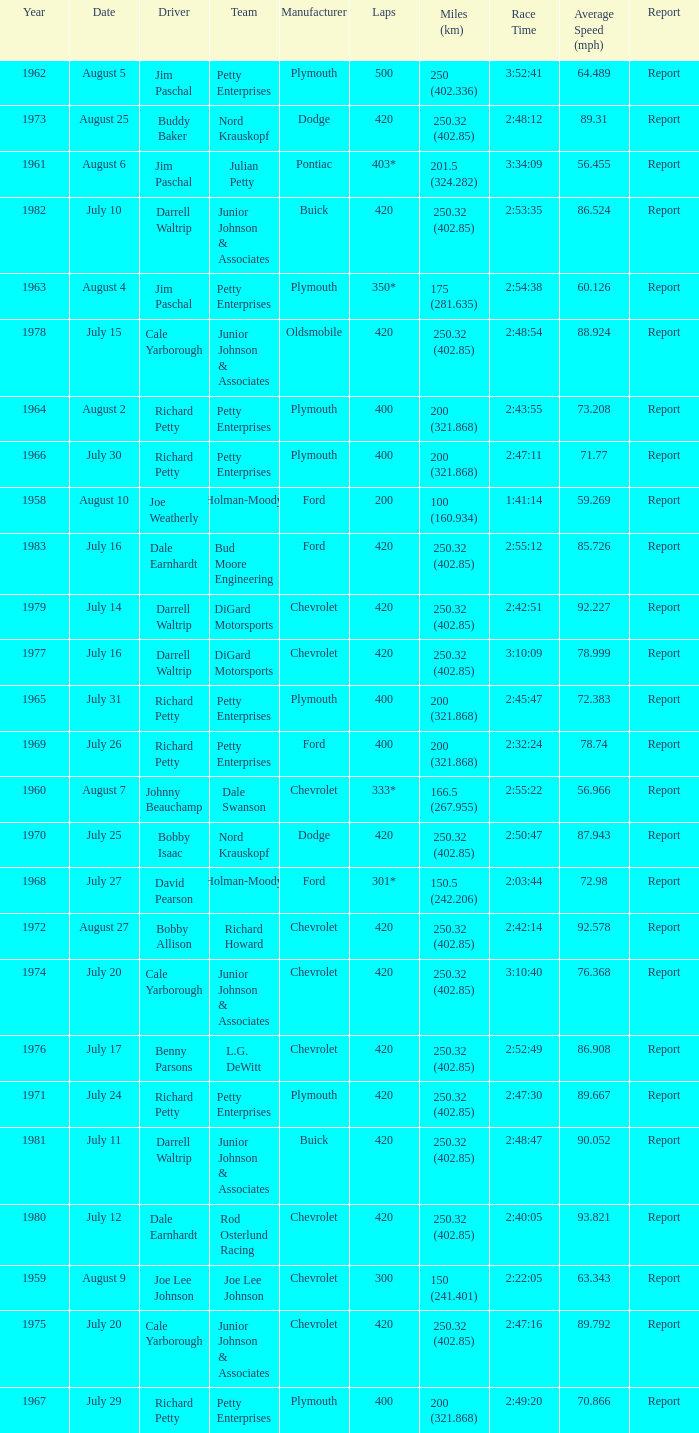What year had a race with 301* laps? 1968.0. 